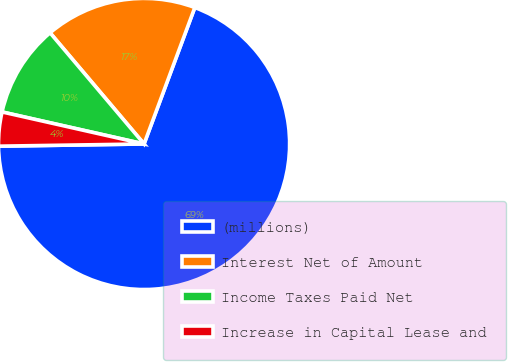Convert chart. <chart><loc_0><loc_0><loc_500><loc_500><pie_chart><fcel>(millions)<fcel>Interest Net of Amount<fcel>Income Taxes Paid Net<fcel>Increase in Capital Lease and<nl><fcel>69.09%<fcel>16.84%<fcel>10.3%<fcel>3.77%<nl></chart> 